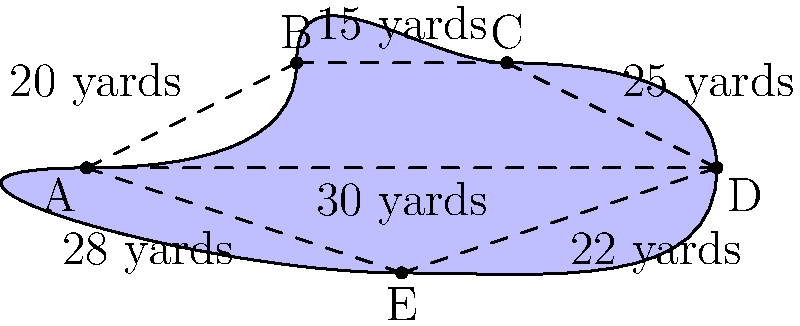As a seasoned golf commentator, you're analyzing a challenging water hazard on the course where Tiger Woods is playing. The irregularly shaped water hazard can be approximated by a polygon ABCDE, as shown in the diagram. Given the distances between the points, calculate the area of this water hazard in square yards. How might this hazard impact Tiger's strategy on this hole? Let's approach this step-by-step, using a method that even a non-mathematician like myself can appreciate:

1) First, we'll divide the polygon into triangles. We can create four triangles: ABC, ACD, ADE, and AEF.

2) For each triangle, we'll use Heron's formula to calculate its area. Heron's formula states that the area of a triangle with sides $a$, $b$, and $c$ is:

   $A = \sqrt{s(s-a)(s-b)(s-c)}$

   where $s = \frac{a+b+c}{2}$ (half the perimeter)

3) Let's calculate each triangle's area:

   Triangle ABC:
   $a = 20$, $b = 15$, $c = 30$
   $s = \frac{20+15+30}{2} = 32.5$
   $A_{ABC} = \sqrt{32.5(32.5-20)(32.5-15)(32.5-30)} = 150$ sq yards

   Triangle ACD:
   $a = 30$, $b = 25$, $c = 30$
   $s = \frac{30+25+30}{2} = 42.5$
   $A_{ACD} = \sqrt{42.5(42.5-30)(42.5-25)(42.5-30)} = 360.5$ sq yards

   Triangle ADE:
   $a = 30$, $b = 22$, $c = 28$
   $s = \frac{30+22+28}{2} = 40$
   $A_{ADE} = \sqrt{40(40-30)(40-22)(40-28)} = 292.8$ sq yards

4) The total area is the sum of these triangle areas:

   $A_{total} = 150 + 360.5 + 292.8 = 803.3$ sq yards

5) Rounding to the nearest whole number, we get 803 sq yards.

As for Tiger's strategy, a water hazard of this size would certainly require careful consideration. He'd need to assess whether to play it safe and lay up short of the hazard, or attempt to carry it if the reward is worth the risk. Knowing Tiger's aggressive style, he might just go for it!
Answer: 803 square yards 